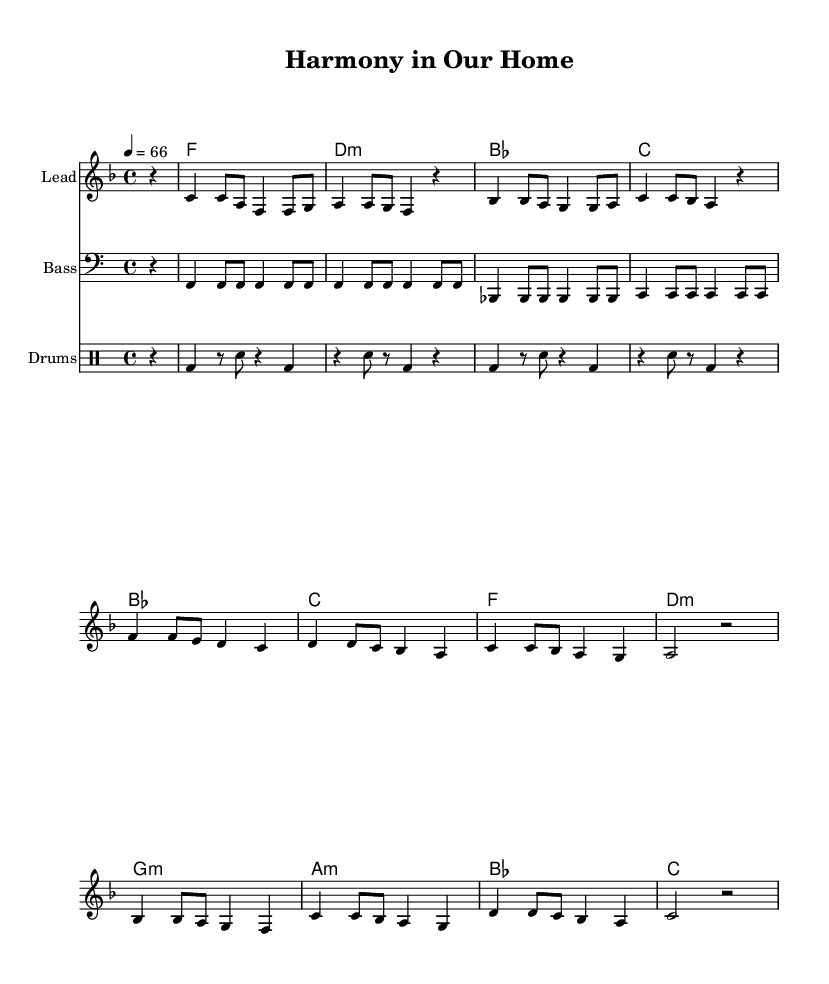What is the key signature of this music? The key signature is F major, which has one flat (B flat). You can identify it by looking at the beginning of the staff where the flat is indicated.
Answer: F major What is the time signature in this piece? The time signature is 4/4, which is shown at the beginning of the score. This means there are four beats in each measure.
Answer: 4/4 What is the tempo marking for this composition? The tempo marking is 4 equals 66, indicating that the quarter note is set to a speed of 66 beats per minute. This is typically noted at the beginning of the piece.
Answer: 66 Identify one musical instrument featured in the score. The score includes a Lead instrument which is indicated at the top of the staff next to the melody.
Answer: Lead How many measures are contained in the melody? The melody contains a total of 16 measures, which can be counted by looking at the end of each line and identifying the divisions between measures.
Answer: 16 What recurring theme is present in the chorus lyrics? The recurring theme is about togetherness and harmony, as emphasized in the words, "Together we stand, hand in hand." This theme reinforces the spirit of communal living.
Answer: Togetherness What are the drum patterns used in this score? The drum patterns consist of a bass drum and snare drum combination that follows a specific rhythmic structure throughout the song. This can be observed in the drum staff.
Answer: Bass and snare 